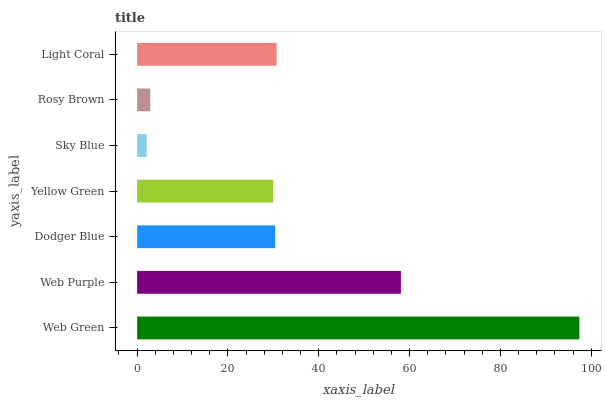Is Sky Blue the minimum?
Answer yes or no. Yes. Is Web Green the maximum?
Answer yes or no. Yes. Is Web Purple the minimum?
Answer yes or no. No. Is Web Purple the maximum?
Answer yes or no. No. Is Web Green greater than Web Purple?
Answer yes or no. Yes. Is Web Purple less than Web Green?
Answer yes or no. Yes. Is Web Purple greater than Web Green?
Answer yes or no. No. Is Web Green less than Web Purple?
Answer yes or no. No. Is Dodger Blue the high median?
Answer yes or no. Yes. Is Dodger Blue the low median?
Answer yes or no. Yes. Is Sky Blue the high median?
Answer yes or no. No. Is Web Purple the low median?
Answer yes or no. No. 